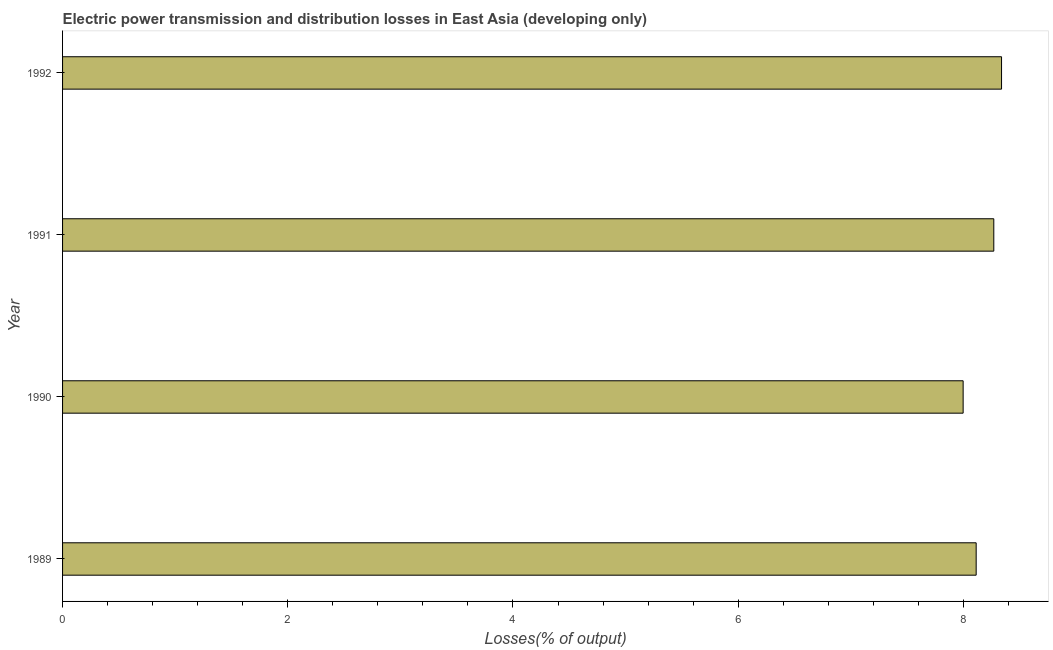Does the graph contain any zero values?
Your answer should be very brief. No. Does the graph contain grids?
Give a very brief answer. No. What is the title of the graph?
Keep it short and to the point. Electric power transmission and distribution losses in East Asia (developing only). What is the label or title of the X-axis?
Your answer should be compact. Losses(% of output). What is the label or title of the Y-axis?
Your response must be concise. Year. What is the electric power transmission and distribution losses in 1989?
Make the answer very short. 8.11. Across all years, what is the maximum electric power transmission and distribution losses?
Keep it short and to the point. 8.34. Across all years, what is the minimum electric power transmission and distribution losses?
Ensure brevity in your answer.  8. What is the sum of the electric power transmission and distribution losses?
Your response must be concise. 32.72. What is the difference between the electric power transmission and distribution losses in 1990 and 1991?
Make the answer very short. -0.27. What is the average electric power transmission and distribution losses per year?
Your response must be concise. 8.18. What is the median electric power transmission and distribution losses?
Provide a succinct answer. 8.19. In how many years, is the electric power transmission and distribution losses greater than 7.6 %?
Provide a short and direct response. 4. Is the electric power transmission and distribution losses in 1989 less than that in 1992?
Ensure brevity in your answer.  Yes. What is the difference between the highest and the second highest electric power transmission and distribution losses?
Provide a short and direct response. 0.07. Is the sum of the electric power transmission and distribution losses in 1989 and 1992 greater than the maximum electric power transmission and distribution losses across all years?
Provide a succinct answer. Yes. What is the difference between the highest and the lowest electric power transmission and distribution losses?
Your answer should be compact. 0.34. In how many years, is the electric power transmission and distribution losses greater than the average electric power transmission and distribution losses taken over all years?
Make the answer very short. 2. Are all the bars in the graph horizontal?
Offer a very short reply. Yes. How many years are there in the graph?
Ensure brevity in your answer.  4. What is the difference between two consecutive major ticks on the X-axis?
Give a very brief answer. 2. What is the Losses(% of output) of 1989?
Your response must be concise. 8.11. What is the Losses(% of output) in 1990?
Provide a short and direct response. 8. What is the Losses(% of output) of 1991?
Your response must be concise. 8.27. What is the Losses(% of output) of 1992?
Offer a very short reply. 8.34. What is the difference between the Losses(% of output) in 1989 and 1990?
Provide a short and direct response. 0.12. What is the difference between the Losses(% of output) in 1989 and 1991?
Provide a succinct answer. -0.16. What is the difference between the Losses(% of output) in 1989 and 1992?
Keep it short and to the point. -0.23. What is the difference between the Losses(% of output) in 1990 and 1991?
Provide a short and direct response. -0.27. What is the difference between the Losses(% of output) in 1990 and 1992?
Ensure brevity in your answer.  -0.34. What is the difference between the Losses(% of output) in 1991 and 1992?
Your answer should be compact. -0.07. What is the ratio of the Losses(% of output) in 1989 to that in 1991?
Give a very brief answer. 0.98. What is the ratio of the Losses(% of output) in 1989 to that in 1992?
Offer a very short reply. 0.97. What is the ratio of the Losses(% of output) in 1990 to that in 1991?
Ensure brevity in your answer.  0.97. What is the ratio of the Losses(% of output) in 1990 to that in 1992?
Make the answer very short. 0.96. 